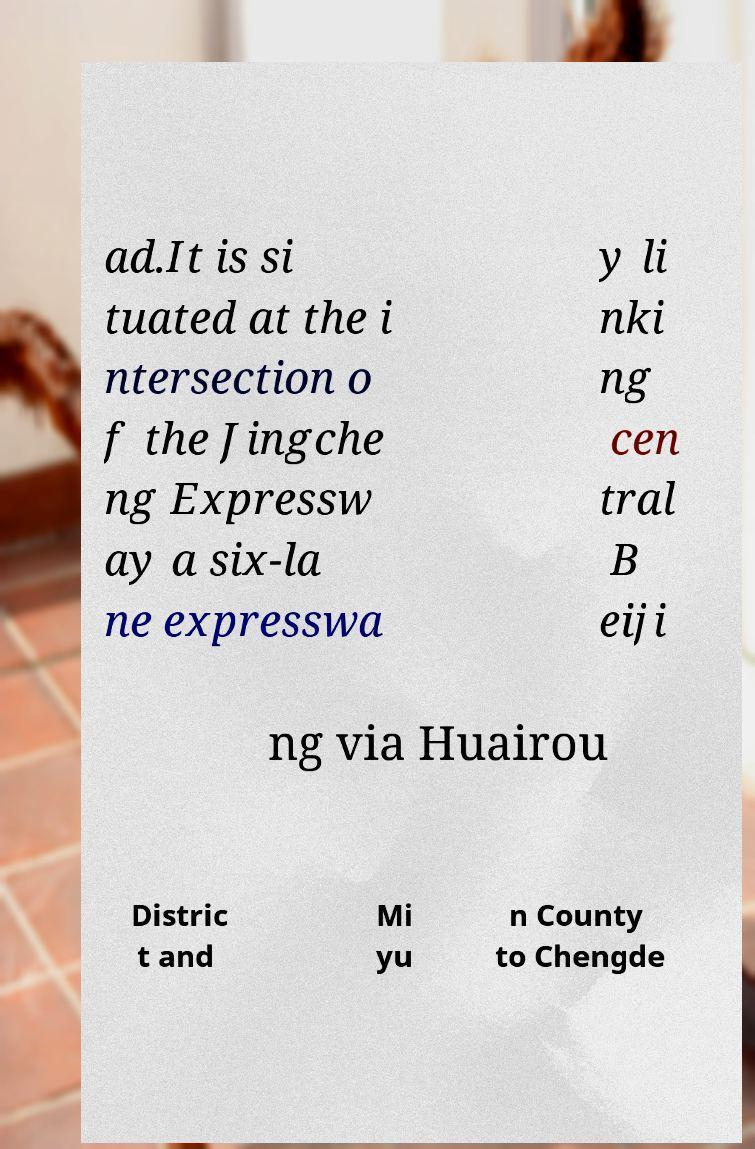Could you extract and type out the text from this image? ad.It is si tuated at the i ntersection o f the Jingche ng Expressw ay a six-la ne expresswa y li nki ng cen tral B eiji ng via Huairou Distric t and Mi yu n County to Chengde 